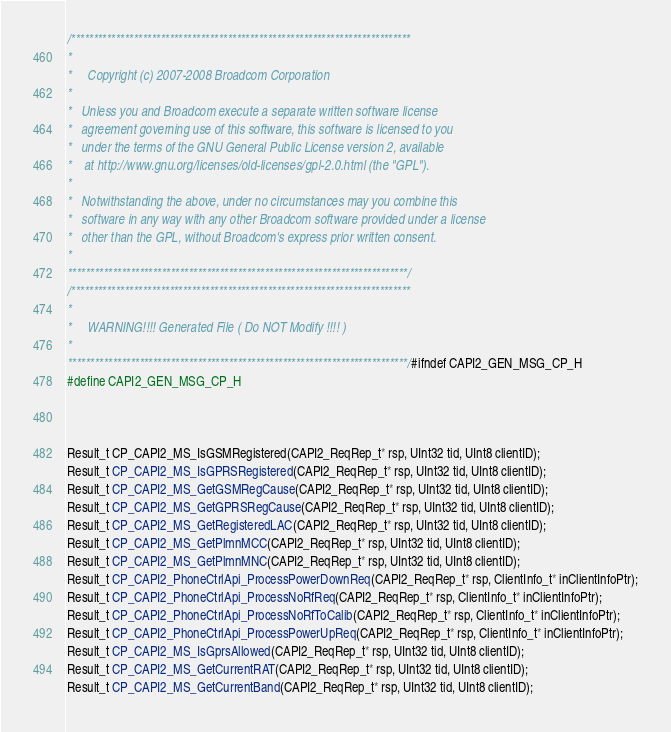Convert code to text. <code><loc_0><loc_0><loc_500><loc_500><_C_>/****************************************************************************
*																			
*     Copyright (c) 2007-2008 Broadcom Corporation								
*																			
*   Unless you and Broadcom execute a separate written software license		
*   agreement governing use of this software, this software is licensed to you	
*   under the terms of the GNU General Public License version 2, available	
*    at http://www.gnu.org/licenses/old-licenses/gpl-2.0.html (the "GPL").	
*																			
*   Notwithstanding the above, under no circumstances may you combine this	
*   software in any way with any other Broadcom software provided under a license 
*   other than the GPL, without Broadcom's express prior written consent.	
*																			
****************************************************************************/
/****************************************************************************
*																			
*     WARNING!!!! Generated File ( Do NOT Modify !!!! )					
*																			
****************************************************************************/#ifndef CAPI2_GEN_MSG_CP_H
#define CAPI2_GEN_MSG_CP_H



Result_t CP_CAPI2_MS_IsGSMRegistered(CAPI2_ReqRep_t* rsp, UInt32 tid, UInt8 clientID);
Result_t CP_CAPI2_MS_IsGPRSRegistered(CAPI2_ReqRep_t* rsp, UInt32 tid, UInt8 clientID);
Result_t CP_CAPI2_MS_GetGSMRegCause(CAPI2_ReqRep_t* rsp, UInt32 tid, UInt8 clientID);
Result_t CP_CAPI2_MS_GetGPRSRegCause(CAPI2_ReqRep_t* rsp, UInt32 tid, UInt8 clientID);
Result_t CP_CAPI2_MS_GetRegisteredLAC(CAPI2_ReqRep_t* rsp, UInt32 tid, UInt8 clientID);
Result_t CP_CAPI2_MS_GetPlmnMCC(CAPI2_ReqRep_t* rsp, UInt32 tid, UInt8 clientID);
Result_t CP_CAPI2_MS_GetPlmnMNC(CAPI2_ReqRep_t* rsp, UInt32 tid, UInt8 clientID);
Result_t CP_CAPI2_PhoneCtrlApi_ProcessPowerDownReq(CAPI2_ReqRep_t* rsp, ClientInfo_t* inClientInfoPtr);
Result_t CP_CAPI2_PhoneCtrlApi_ProcessNoRfReq(CAPI2_ReqRep_t* rsp, ClientInfo_t* inClientInfoPtr);
Result_t CP_CAPI2_PhoneCtrlApi_ProcessNoRfToCalib(CAPI2_ReqRep_t* rsp, ClientInfo_t* inClientInfoPtr);
Result_t CP_CAPI2_PhoneCtrlApi_ProcessPowerUpReq(CAPI2_ReqRep_t* rsp, ClientInfo_t* inClientInfoPtr);
Result_t CP_CAPI2_MS_IsGprsAllowed(CAPI2_ReqRep_t* rsp, UInt32 tid, UInt8 clientID);
Result_t CP_CAPI2_MS_GetCurrentRAT(CAPI2_ReqRep_t* rsp, UInt32 tid, UInt8 clientID);
Result_t CP_CAPI2_MS_GetCurrentBand(CAPI2_ReqRep_t* rsp, UInt32 tid, UInt8 clientID);</code> 